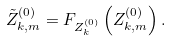Convert formula to latex. <formula><loc_0><loc_0><loc_500><loc_500>\tilde { Z } _ { k , m } ^ { ( 0 ) } = F _ { Z _ { k } ^ { ( 0 ) } } \left ( Z _ { k , m } ^ { ( 0 ) } \right ) .</formula> 